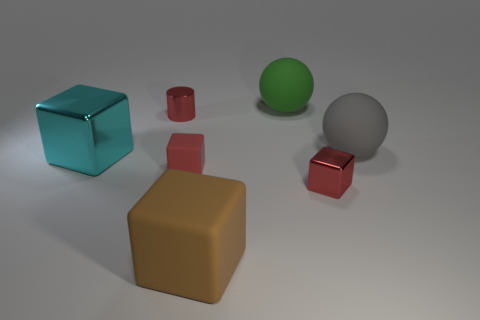Are any big yellow rubber blocks visible?
Make the answer very short. No. Does the green thing have the same shape as the red rubber thing?
Keep it short and to the point. No. What number of small things are yellow metal cubes or cyan shiny cubes?
Offer a terse response. 0. What is the color of the large metallic thing?
Make the answer very short. Cyan. What is the shape of the thing that is on the right side of the shiny block right of the big brown cube?
Your response must be concise. Sphere. Are there any green things that have the same material as the large gray thing?
Make the answer very short. Yes. There is a metallic object in front of the cyan thing; is it the same size as the red matte cube?
Give a very brief answer. Yes. How many brown things are either cubes or big rubber blocks?
Ensure brevity in your answer.  1. There is a block that is left of the tiny red cylinder; what is its material?
Provide a succinct answer. Metal. There is a block right of the brown thing; what number of tiny rubber blocks are behind it?
Keep it short and to the point. 1. 